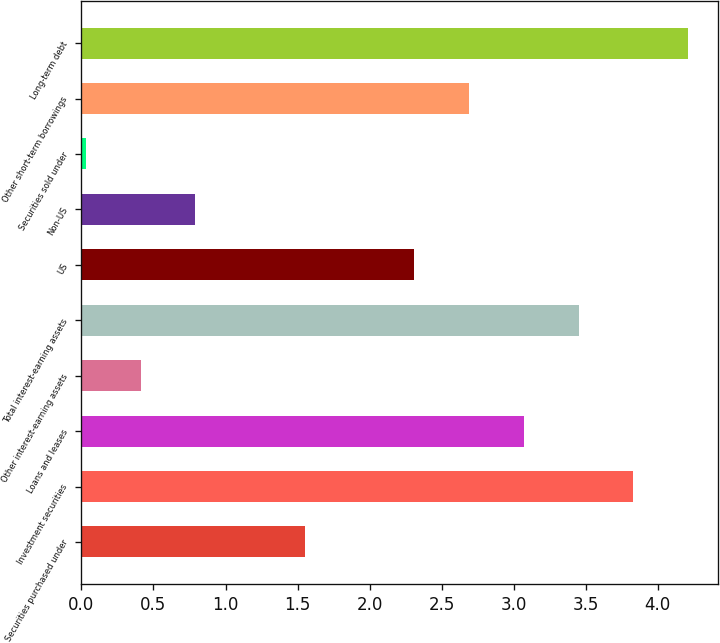<chart> <loc_0><loc_0><loc_500><loc_500><bar_chart><fcel>Securities purchased under<fcel>Investment securities<fcel>Loans and leases<fcel>Other interest-earning assets<fcel>Total interest-earning assets<fcel>US<fcel>Non-US<fcel>Securities sold under<fcel>Other short-term borrowings<fcel>Long-term debt<nl><fcel>1.55<fcel>3.83<fcel>3.07<fcel>0.41<fcel>3.45<fcel>2.31<fcel>0.79<fcel>0.03<fcel>2.69<fcel>4.21<nl></chart> 